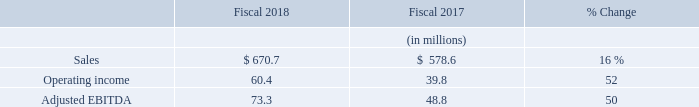Cubic Transportation Systems
Sales: CTS sales increased 16% to $670.7 million in 2018 compared to $578.6 million in 2017 and were higher in North America and the U.K., but were slightly lower in Australia. Sales in 2018 were higher in the U.S. primarily due to system development on the New York New Fare Payment System contract, which was awarded in October 2017. Increased work on both development and service contracts, including work on new change orders in London also increased CTS sales for the year. Sales were also positively impacted in the U.K. and Australia due to the impact of exchange rates. The average exchange rates between the prevailing currencies in our foreign operations and the U.S. dollar resulted in an increase in CTS sales of $12.4 million for 2018 compared to 2017, primarily due to the strengthening of the British Pound against the U.S. dollar.
Amortization of Purchased Intangibles: Amortization of purchased intangibles included in the CTS operating results totaled $5.2 million in 2018 and $5.7 million in 2017.
Operating Income: CTS operating income increased 52% in 2018 to $60.4 million compared to $39.8 million in 2017. For 2018, operating income was higher from increased volumes of system development work and services, including work on new projects and change orders, primarily in North America and the U.K. Operating income was also higher due to operational efficiencies and reductions in R&D spending. R&D expenses for CTS in 2017 included $6.4 million of system development expenses related to our anticipated contract with the New York Metropolitan Transit Authority that was awarded in early fiscal 2018; such expenses incurred in 2018 on this contract are classified as cost of sales. During the first quarter of fiscal year 2018 CTS implemented our new enterprise resource planning (ERP) system, and as a result began depreciating the cost of certain capitalized software into its operating results. This resulted in a decrease in operating income of $4.2 million between fiscal 2017 and fiscal 2018. The average exchange rates between the prevailing currency in our foreign operations and the U.S. dollar resulted in an increase in CTS operating income of $2.2 million for 2018 compared to 2017.
Adjusted EBITDA: CTS Adjusted EBITDA increased 50% to $73.3 million in 2018 compared to $48.8 million in 2017 primarily due to the same items described in the operating income section above. The increase in Adjusted EBITDA was primarily driven by the same factors that drove the increase in operating income described above excluding the increase in depreciation and decrease in amortization which are excluded from Adjusted EBITDA.
What is the percentage increase in CTS sales in 2018? 16%. What resulted in a higher operating income? Increased volumes of system development work and services, including work on new projects and change orders, primarily in north america and the u.k. operating income was also higher due to operational efficiencies and reductions in r&d spending. What is the Sales for 2018?
Answer scale should be: million. $ 670.7. In which year was the amortization of purchased intangibles included in the CTS operating results lower? 5.2<5.7
Answer: 2018. What is the change in CTS adjusted EBITDA?
Answer scale should be: million. 73.3-48.8
Answer: 24.5. What is the average operating income in 2017 and 2018?
Answer scale should be: million. (60.4+39.8)/2
Answer: 50.1. 